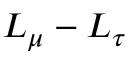<formula> <loc_0><loc_0><loc_500><loc_500>L _ { \mu } - L _ { \tau }</formula> 